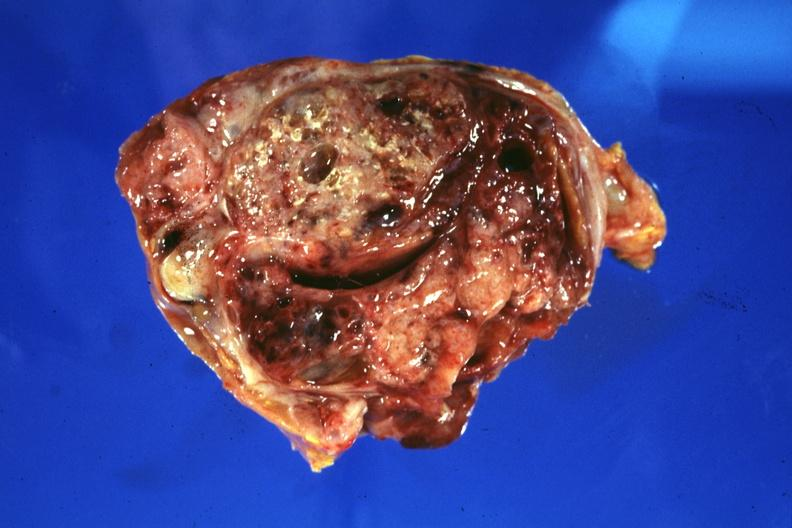s carcinoma present?
Answer the question using a single word or phrase. No 